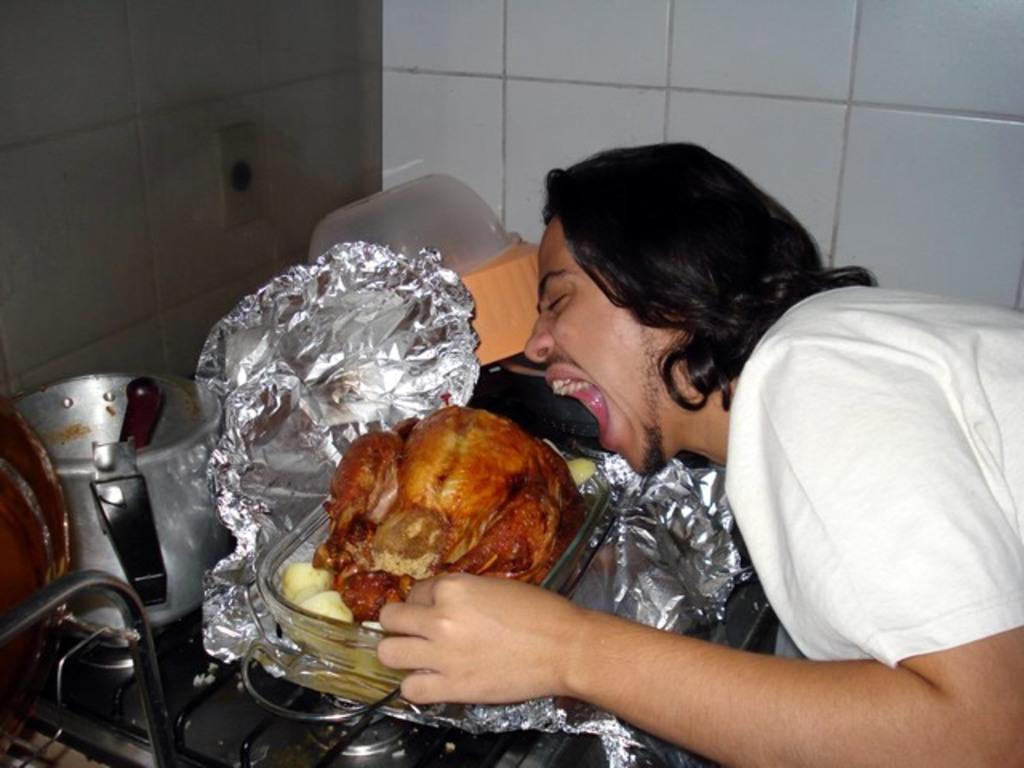Who or what is on the right side of the image? There is a person on the right side of the image. What can be seen in the center of the image? In the center of the image, there are vessels, a paper, meat, containers, and a stove. What is the purpose of the paper in the image? The purpose of the paper is not specified in the image, but it could be used for various purposes such as wrapping or labeling. What type of surface is visible at the top of the image? There is a wall at the top of the image. How many ladybugs are crawling on the meat in the image? There are no ladybugs present in the image; it only shows vessels, a paper, meat, containers, and a stove in the center. What type of news is being reported on the twig in the image? There is no twig or news present in the image. 